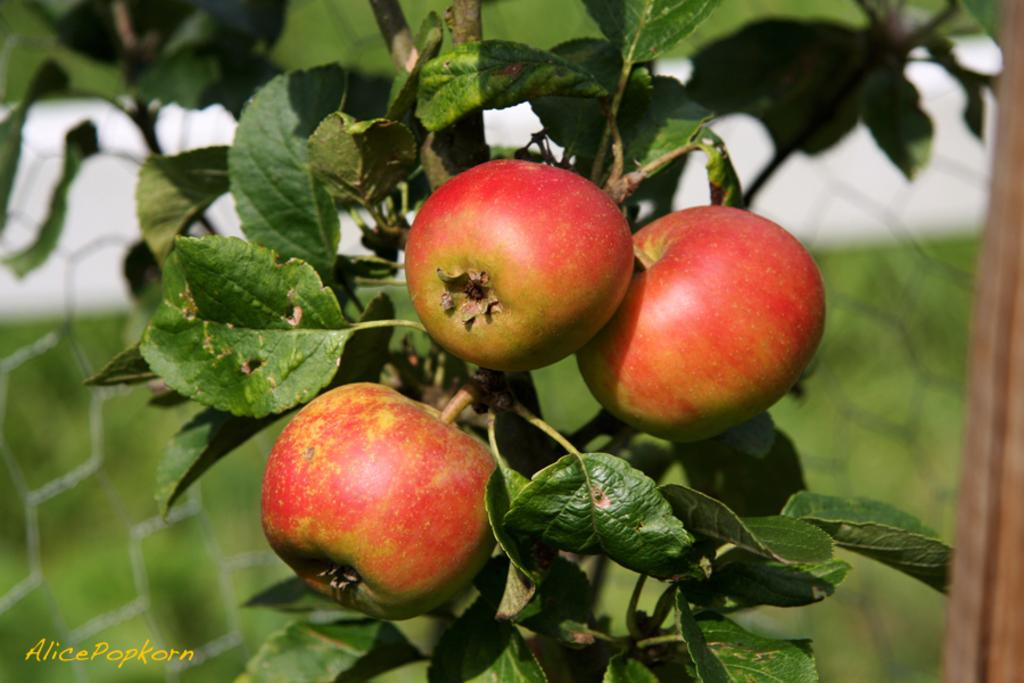What type of living organisms can be seen on the plant in the image? There are fruits on a plant in the image. What else is visible in the image besides the plant? There is some text visible in the bottom left of the image, and there is a fence in the image. Can you describe the background of the image? The background of the image is blurry. What type of song is being played on the drum in the image? There is no drum or song present in the image. 